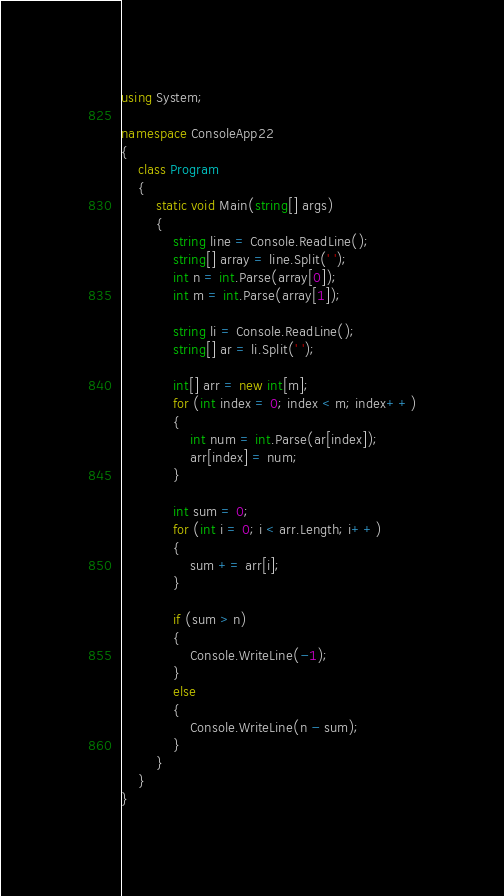Convert code to text. <code><loc_0><loc_0><loc_500><loc_500><_C#_>using System;

namespace ConsoleApp22
{
    class Program
    {
        static void Main(string[] args)
        {
            string line = Console.ReadLine();
            string[] array = line.Split(' ');
            int n = int.Parse(array[0]);
            int m = int.Parse(array[1]);

            string li = Console.ReadLine();
            string[] ar = li.Split(' ');

            int[] arr = new int[m];
            for (int index = 0; index < m; index++)
            {
                int num = int.Parse(ar[index]);
                arr[index] = num;
            }

            int sum = 0;
            for (int i = 0; i < arr.Length; i++)
            {
                sum += arr[i];
            }

            if (sum > n)
            {
                Console.WriteLine(-1);
            }
            else
            {
                Console.WriteLine(n - sum);
            }
        }
    }
}
</code> 